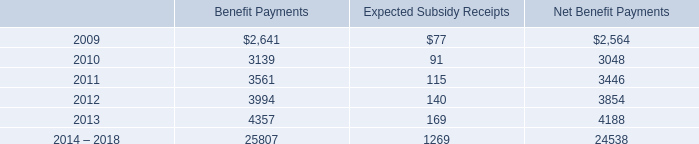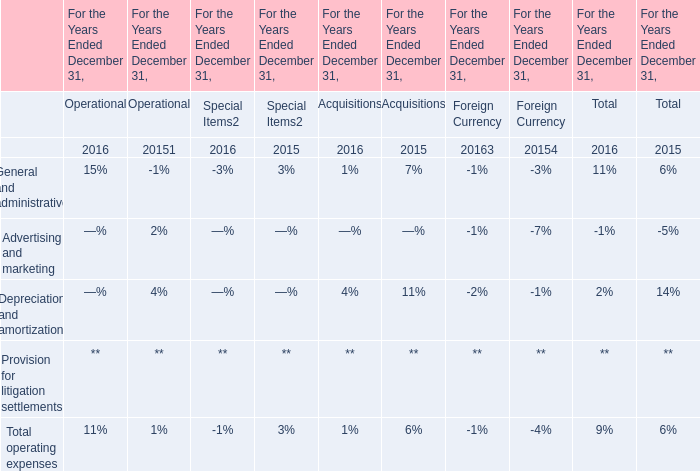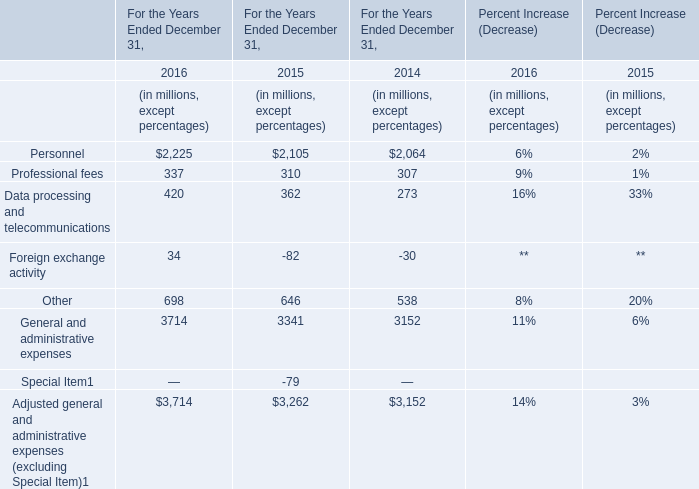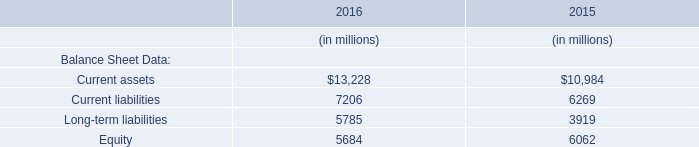In which year is General and administrative expenses the largest? 
Answer: 2016. 